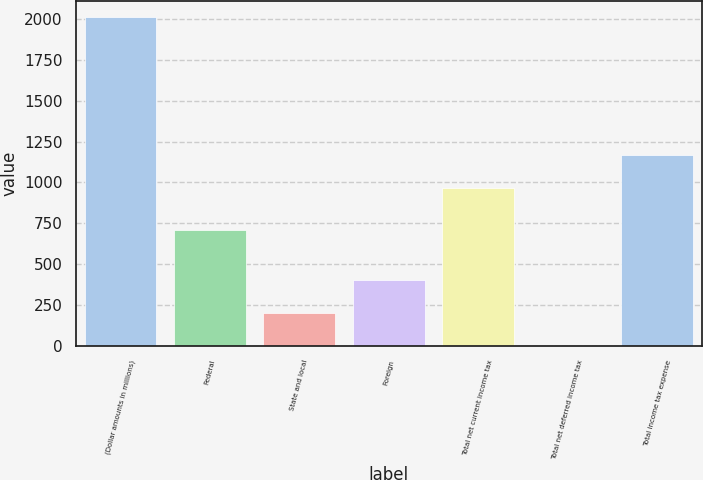<chart> <loc_0><loc_0><loc_500><loc_500><bar_chart><fcel>(Dollar amounts in millions)<fcel>Federal<fcel>State and local<fcel>Foreign<fcel>Total net current income tax<fcel>Total net deferred income tax<fcel>Total income tax expense<nl><fcel>2010<fcel>708<fcel>203.7<fcel>404.4<fcel>968<fcel>3<fcel>1168.7<nl></chart> 